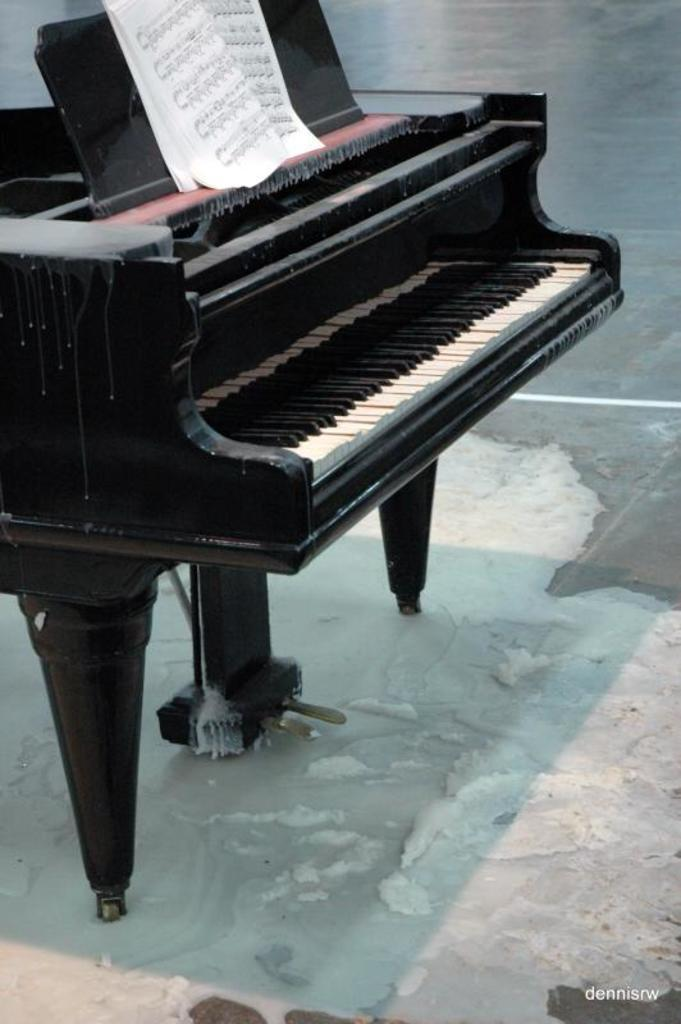What musical instrument is visible in the image? There is a piano keyboard in the image. What is placed on top of the piano? There is a paper on the piano. What type of surface is visible in the image? The image shows a floor. What type of leather is being used to make the cattle's shoes in the image? There is no leather, cattle, or shoes present in the image. 